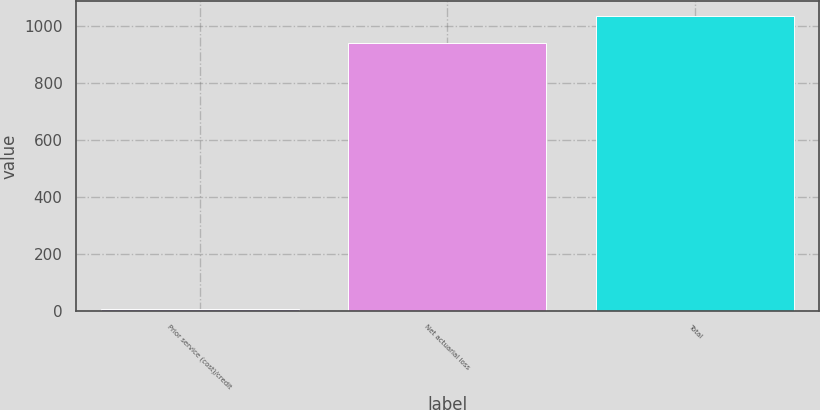Convert chart. <chart><loc_0><loc_0><loc_500><loc_500><bar_chart><fcel>Prior service (cost)/credit<fcel>Net actuarial loss<fcel>Total<nl><fcel>7<fcel>942<fcel>1036.2<nl></chart> 